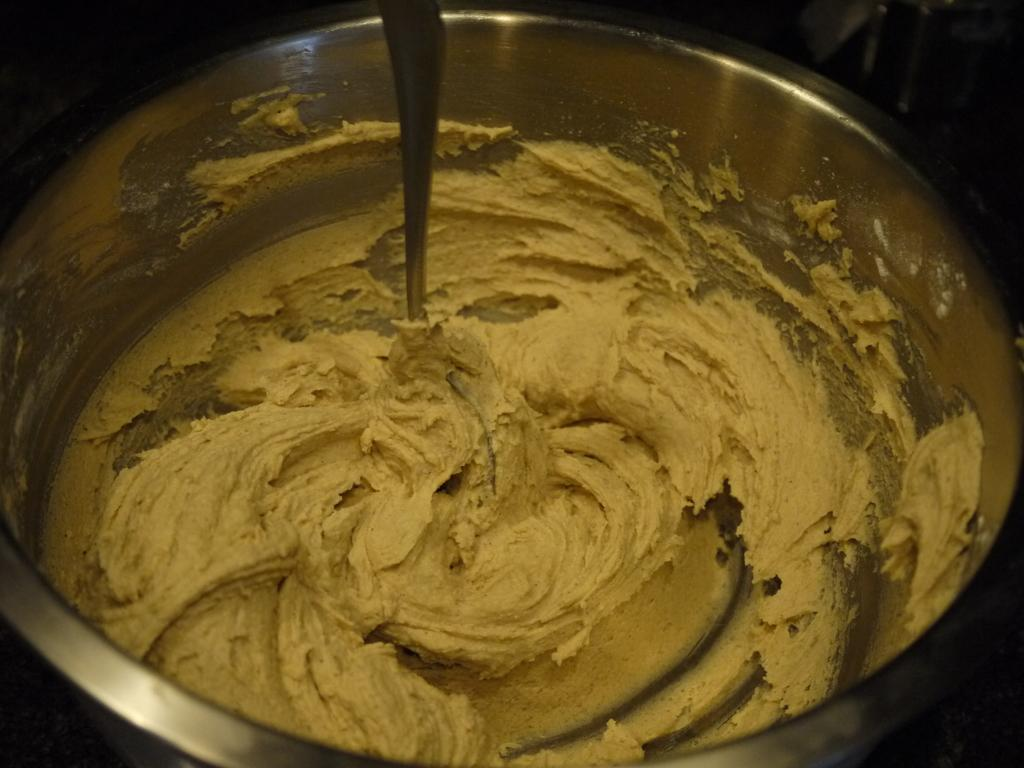What is present in the image related to food? There is food in the image. What utensil can be seen in the image? There is a spoon in the image. How is the spoon positioned in relation to the food? The spoon is placed in a bowl. Can you see any islands in the image? There are no islands present in the image. What type of fruit is being eaten in the image? There is no fruit present in the image, and therefore no fruit being eaten can be observed. 